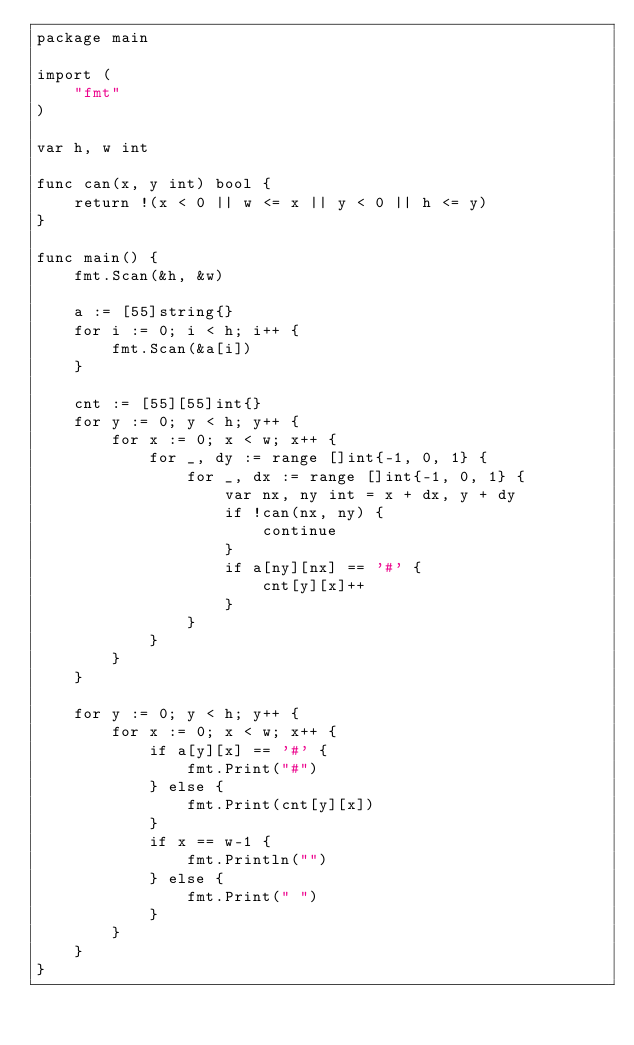Convert code to text. <code><loc_0><loc_0><loc_500><loc_500><_Go_>package main

import (
	"fmt"
)

var h, w int

func can(x, y int) bool {
	return !(x < 0 || w <= x || y < 0 || h <= y)
}

func main() {
	fmt.Scan(&h, &w)

	a := [55]string{}
	for i := 0; i < h; i++ {
		fmt.Scan(&a[i])
	}

	cnt := [55][55]int{}
	for y := 0; y < h; y++ {
		for x := 0; x < w; x++ {
			for _, dy := range []int{-1, 0, 1} {
				for _, dx := range []int{-1, 0, 1} {
					var nx, ny int = x + dx, y + dy
					if !can(nx, ny) {
						continue
					}
					if a[ny][nx] == '#' {
						cnt[y][x]++
					}
				}
			}
		}
	}

	for y := 0; y < h; y++ {
		for x := 0; x < w; x++ {
			if a[y][x] == '#' {
				fmt.Print("#")
			} else {
				fmt.Print(cnt[y][x])
			}
			if x == w-1 {
				fmt.Println("")
			} else {
				fmt.Print(" ")
			}
		}
	}
}
</code> 